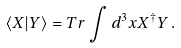<formula> <loc_0><loc_0><loc_500><loc_500>\left \langle X | Y \right \rangle = T r \int d ^ { 3 } x X ^ { \dagger } Y \, .</formula> 